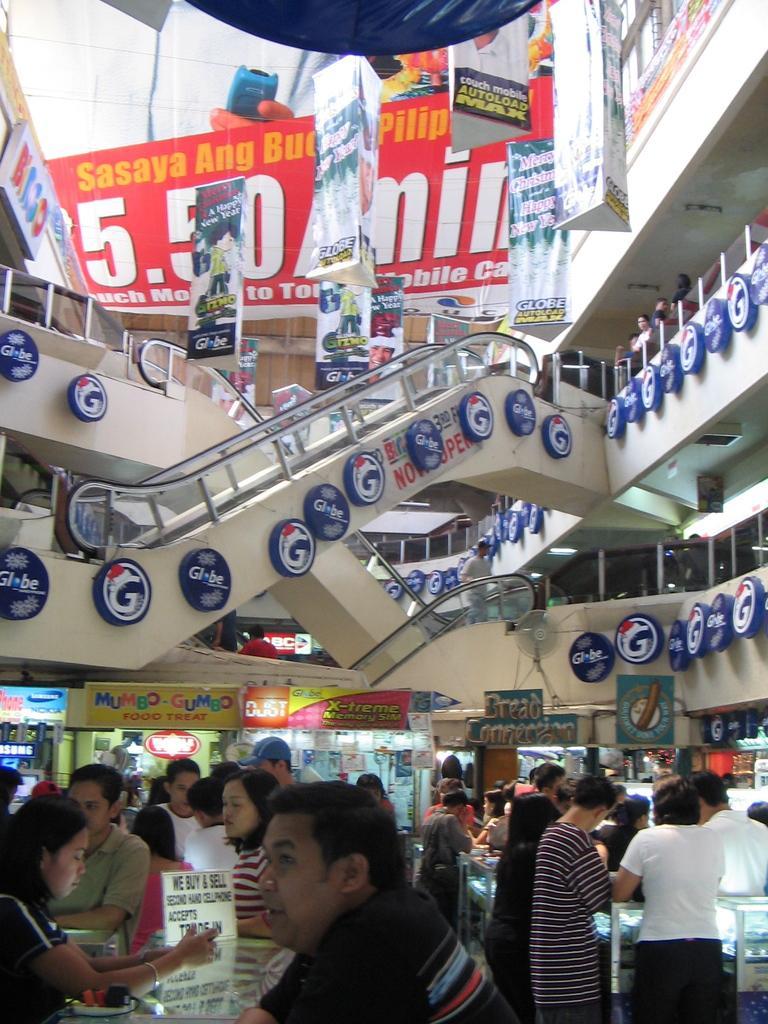In one or two sentences, can you explain what this image depicts? Here men and women are standing, this is a building, these are banners. 